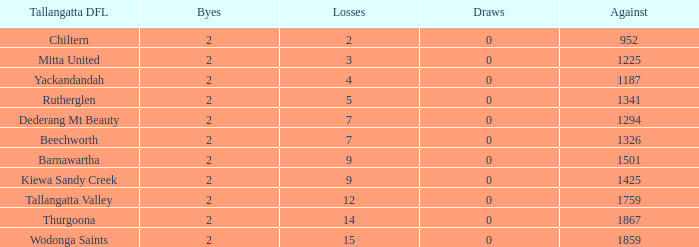What are the fewest draws with less than 7 losses and Mitta United is the Tallagatta DFL? 0.0. 